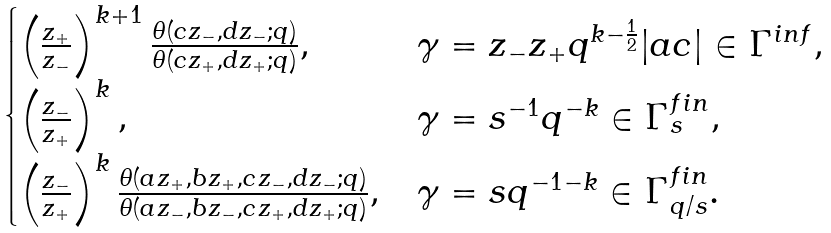Convert formula to latex. <formula><loc_0><loc_0><loc_500><loc_500>\begin{cases} \left ( \frac { z _ { + } } { z _ { - } } \right ) ^ { k + 1 } \frac { \theta ( c z _ { - } , d z _ { - } ; q ) } { \theta ( c z _ { + } , d z _ { + } ; q ) } , & \gamma = z _ { - } z _ { + } q ^ { k - \frac { 1 } { 2 } } | a c | \in \Gamma ^ { i n f } , \\ \left ( \frac { z _ { - } } { z _ { + } } \right ) ^ { k } , & \gamma = s ^ { - 1 } q ^ { - k } \in \Gamma ^ { f \/ i n } _ { s } , \\ \left ( \frac { z _ { - } } { z _ { + } } \right ) ^ { k } \frac { \theta ( a z _ { + } , b z _ { + } , c z _ { - } , d z _ { - } ; q ) } { \theta ( a z _ { - } , b z _ { - } , c z _ { + } , d z _ { + } ; q ) } , & \gamma = s q ^ { - 1 - k } \in \Gamma ^ { f \/ i n } _ { q / s } . \end{cases}</formula> 